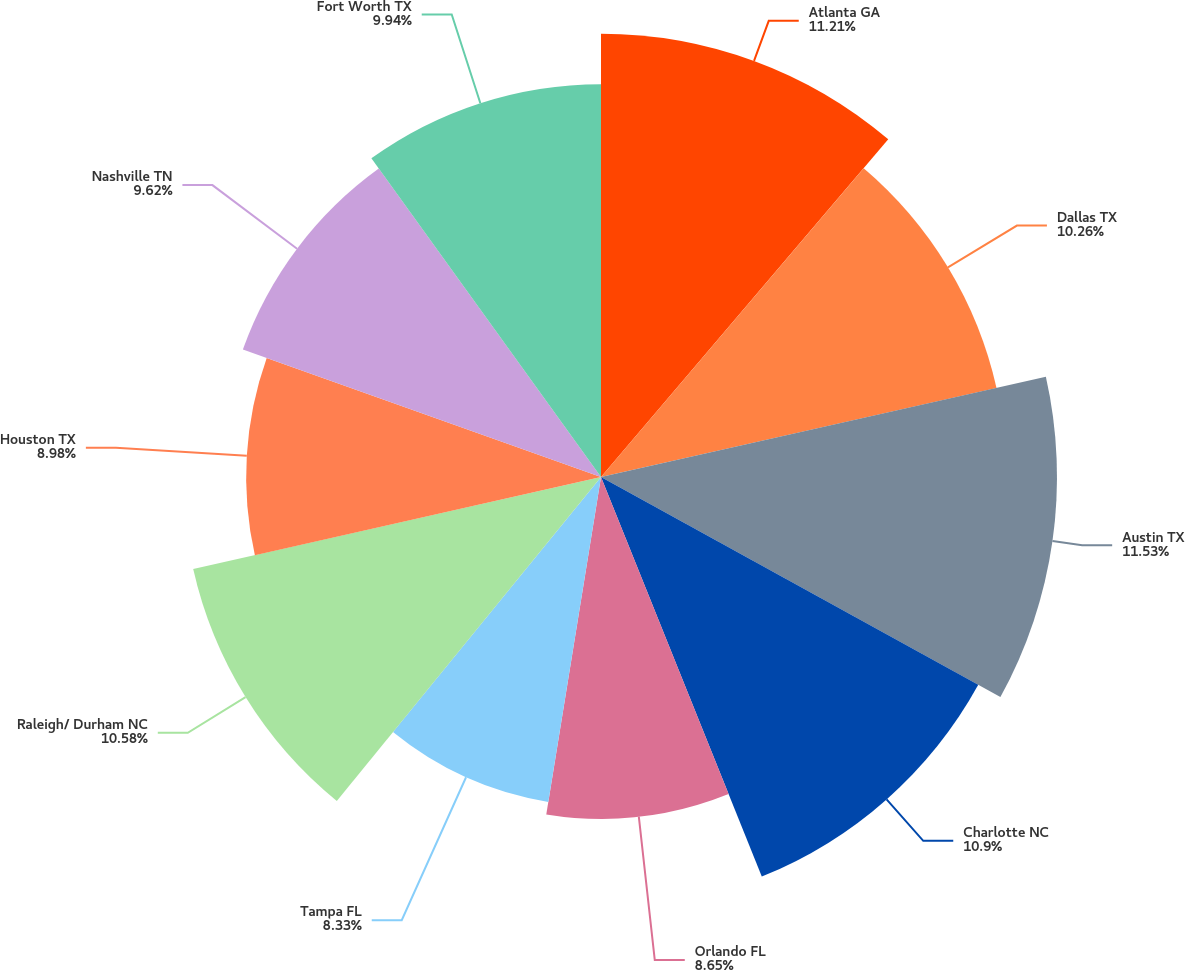Convert chart. <chart><loc_0><loc_0><loc_500><loc_500><pie_chart><fcel>Atlanta GA<fcel>Dallas TX<fcel>Austin TX<fcel>Charlotte NC<fcel>Orlando FL<fcel>Tampa FL<fcel>Raleigh/ Durham NC<fcel>Houston TX<fcel>Nashville TN<fcel>Fort Worth TX<nl><fcel>11.22%<fcel>10.26%<fcel>11.54%<fcel>10.9%<fcel>8.65%<fcel>8.33%<fcel>10.58%<fcel>8.98%<fcel>9.62%<fcel>9.94%<nl></chart> 